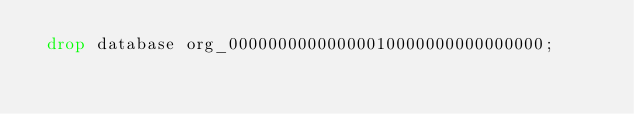Convert code to text. <code><loc_0><loc_0><loc_500><loc_500><_SQL_> drop database org_00000000000000010000000000000000;
</code> 